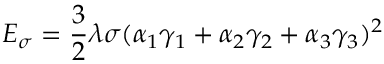Convert formula to latex. <formula><loc_0><loc_0><loc_500><loc_500>E _ { \sigma } = { \frac { 3 } { 2 } } \lambda \sigma ( \alpha _ { 1 } \gamma _ { 1 } + \alpha _ { 2 } \gamma _ { 2 } + \alpha _ { 3 } \gamma _ { 3 } ) ^ { 2 }</formula> 